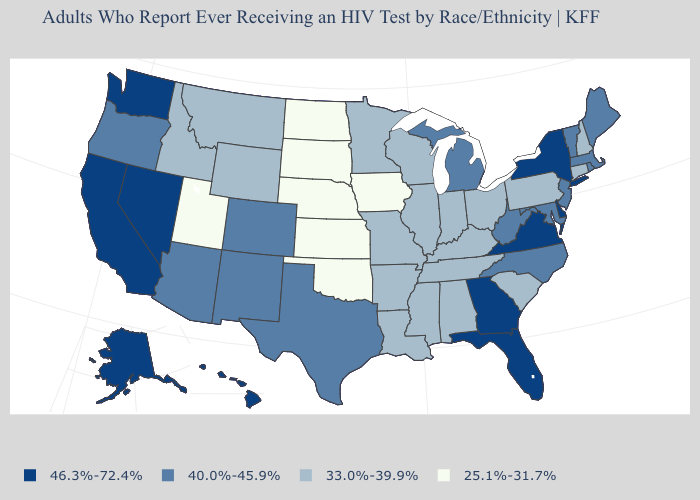What is the highest value in states that border Washington?
Short answer required. 40.0%-45.9%. Name the states that have a value in the range 40.0%-45.9%?
Short answer required. Arizona, Colorado, Maine, Maryland, Massachusetts, Michigan, New Jersey, New Mexico, North Carolina, Oregon, Rhode Island, Texas, Vermont, West Virginia. What is the lowest value in states that border New Hampshire?
Concise answer only. 40.0%-45.9%. What is the value of Kentucky?
Short answer required. 33.0%-39.9%. What is the value of South Dakota?
Quick response, please. 25.1%-31.7%. Does the first symbol in the legend represent the smallest category?
Short answer required. No. Name the states that have a value in the range 40.0%-45.9%?
Concise answer only. Arizona, Colorado, Maine, Maryland, Massachusetts, Michigan, New Jersey, New Mexico, North Carolina, Oregon, Rhode Island, Texas, Vermont, West Virginia. What is the value of Montana?
Give a very brief answer. 33.0%-39.9%. Name the states that have a value in the range 33.0%-39.9%?
Give a very brief answer. Alabama, Arkansas, Connecticut, Idaho, Illinois, Indiana, Kentucky, Louisiana, Minnesota, Mississippi, Missouri, Montana, New Hampshire, Ohio, Pennsylvania, South Carolina, Tennessee, Wisconsin, Wyoming. What is the value of Wyoming?
Keep it brief. 33.0%-39.9%. Does Mississippi have the same value as Wyoming?
Be succinct. Yes. Does Kentucky have the highest value in the USA?
Quick response, please. No. What is the highest value in the West ?
Write a very short answer. 46.3%-72.4%. Is the legend a continuous bar?
Quick response, please. No. Does North Dakota have the highest value in the MidWest?
Concise answer only. No. 